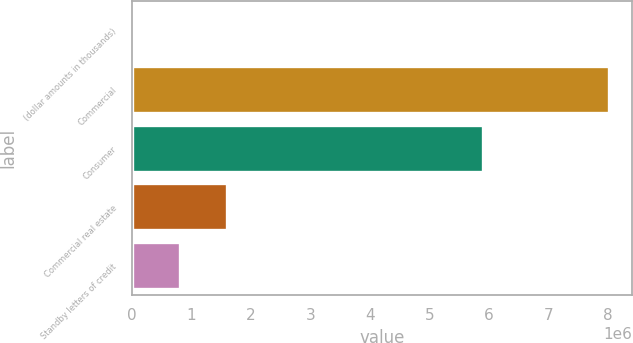<chart> <loc_0><loc_0><loc_500><loc_500><bar_chart><fcel>(dollar amounts in thousands)<fcel>Commercial<fcel>Consumer<fcel>Commercial real estate<fcel>Standby letters of credit<nl><fcel>2011<fcel>8.00607e+06<fcel>5.90384e+06<fcel>1.60282e+06<fcel>802417<nl></chart> 